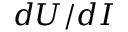Convert formula to latex. <formula><loc_0><loc_0><loc_500><loc_500>d U / d I</formula> 